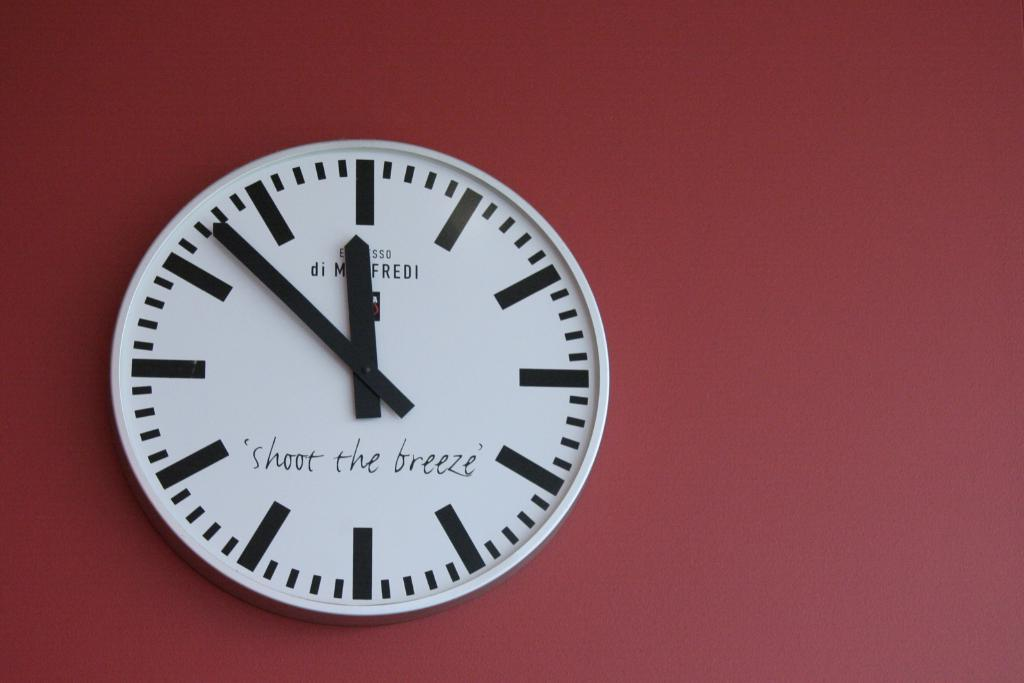Provide a one-sentence caption for the provided image. The time is 11:53 on a clock that says "shoot the breeze.". 